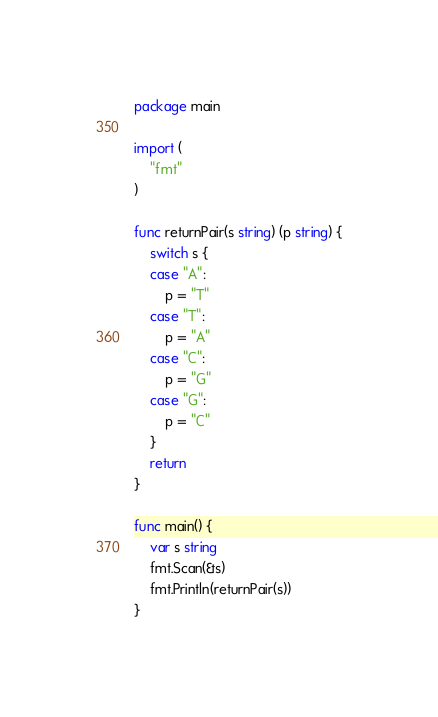<code> <loc_0><loc_0><loc_500><loc_500><_Go_>package main

import (
	"fmt"
)

func returnPair(s string) (p string) {
	switch s {
	case "A":
		p = "T"
	case "T":
		p = "A"
	case "C":
		p = "G"
	case "G":
		p = "C"
	}
	return
}

func main() {
	var s string
	fmt.Scan(&s)
	fmt.Println(returnPair(s))
}
</code> 